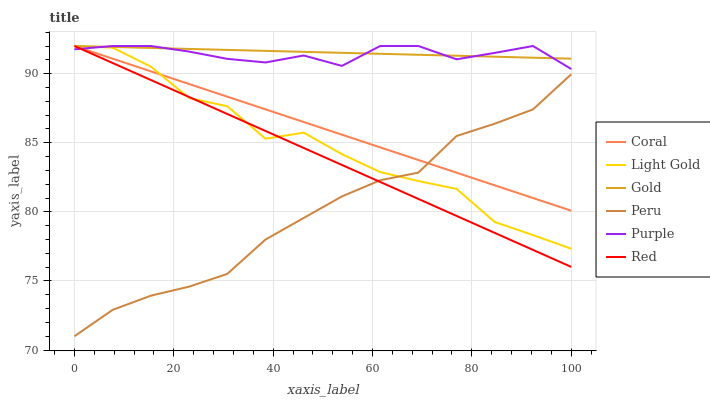Does Peru have the minimum area under the curve?
Answer yes or no. Yes. Does Gold have the maximum area under the curve?
Answer yes or no. Yes. Does Purple have the minimum area under the curve?
Answer yes or no. No. Does Purple have the maximum area under the curve?
Answer yes or no. No. Is Red the smoothest?
Answer yes or no. Yes. Is Light Gold the roughest?
Answer yes or no. Yes. Is Purple the smoothest?
Answer yes or no. No. Is Purple the roughest?
Answer yes or no. No. Does Peru have the lowest value?
Answer yes or no. Yes. Does Purple have the lowest value?
Answer yes or no. No. Does Red have the highest value?
Answer yes or no. Yes. Does Peru have the highest value?
Answer yes or no. No. Is Peru less than Gold?
Answer yes or no. Yes. Is Purple greater than Peru?
Answer yes or no. Yes. Does Gold intersect Purple?
Answer yes or no. Yes. Is Gold less than Purple?
Answer yes or no. No. Is Gold greater than Purple?
Answer yes or no. No. Does Peru intersect Gold?
Answer yes or no. No. 